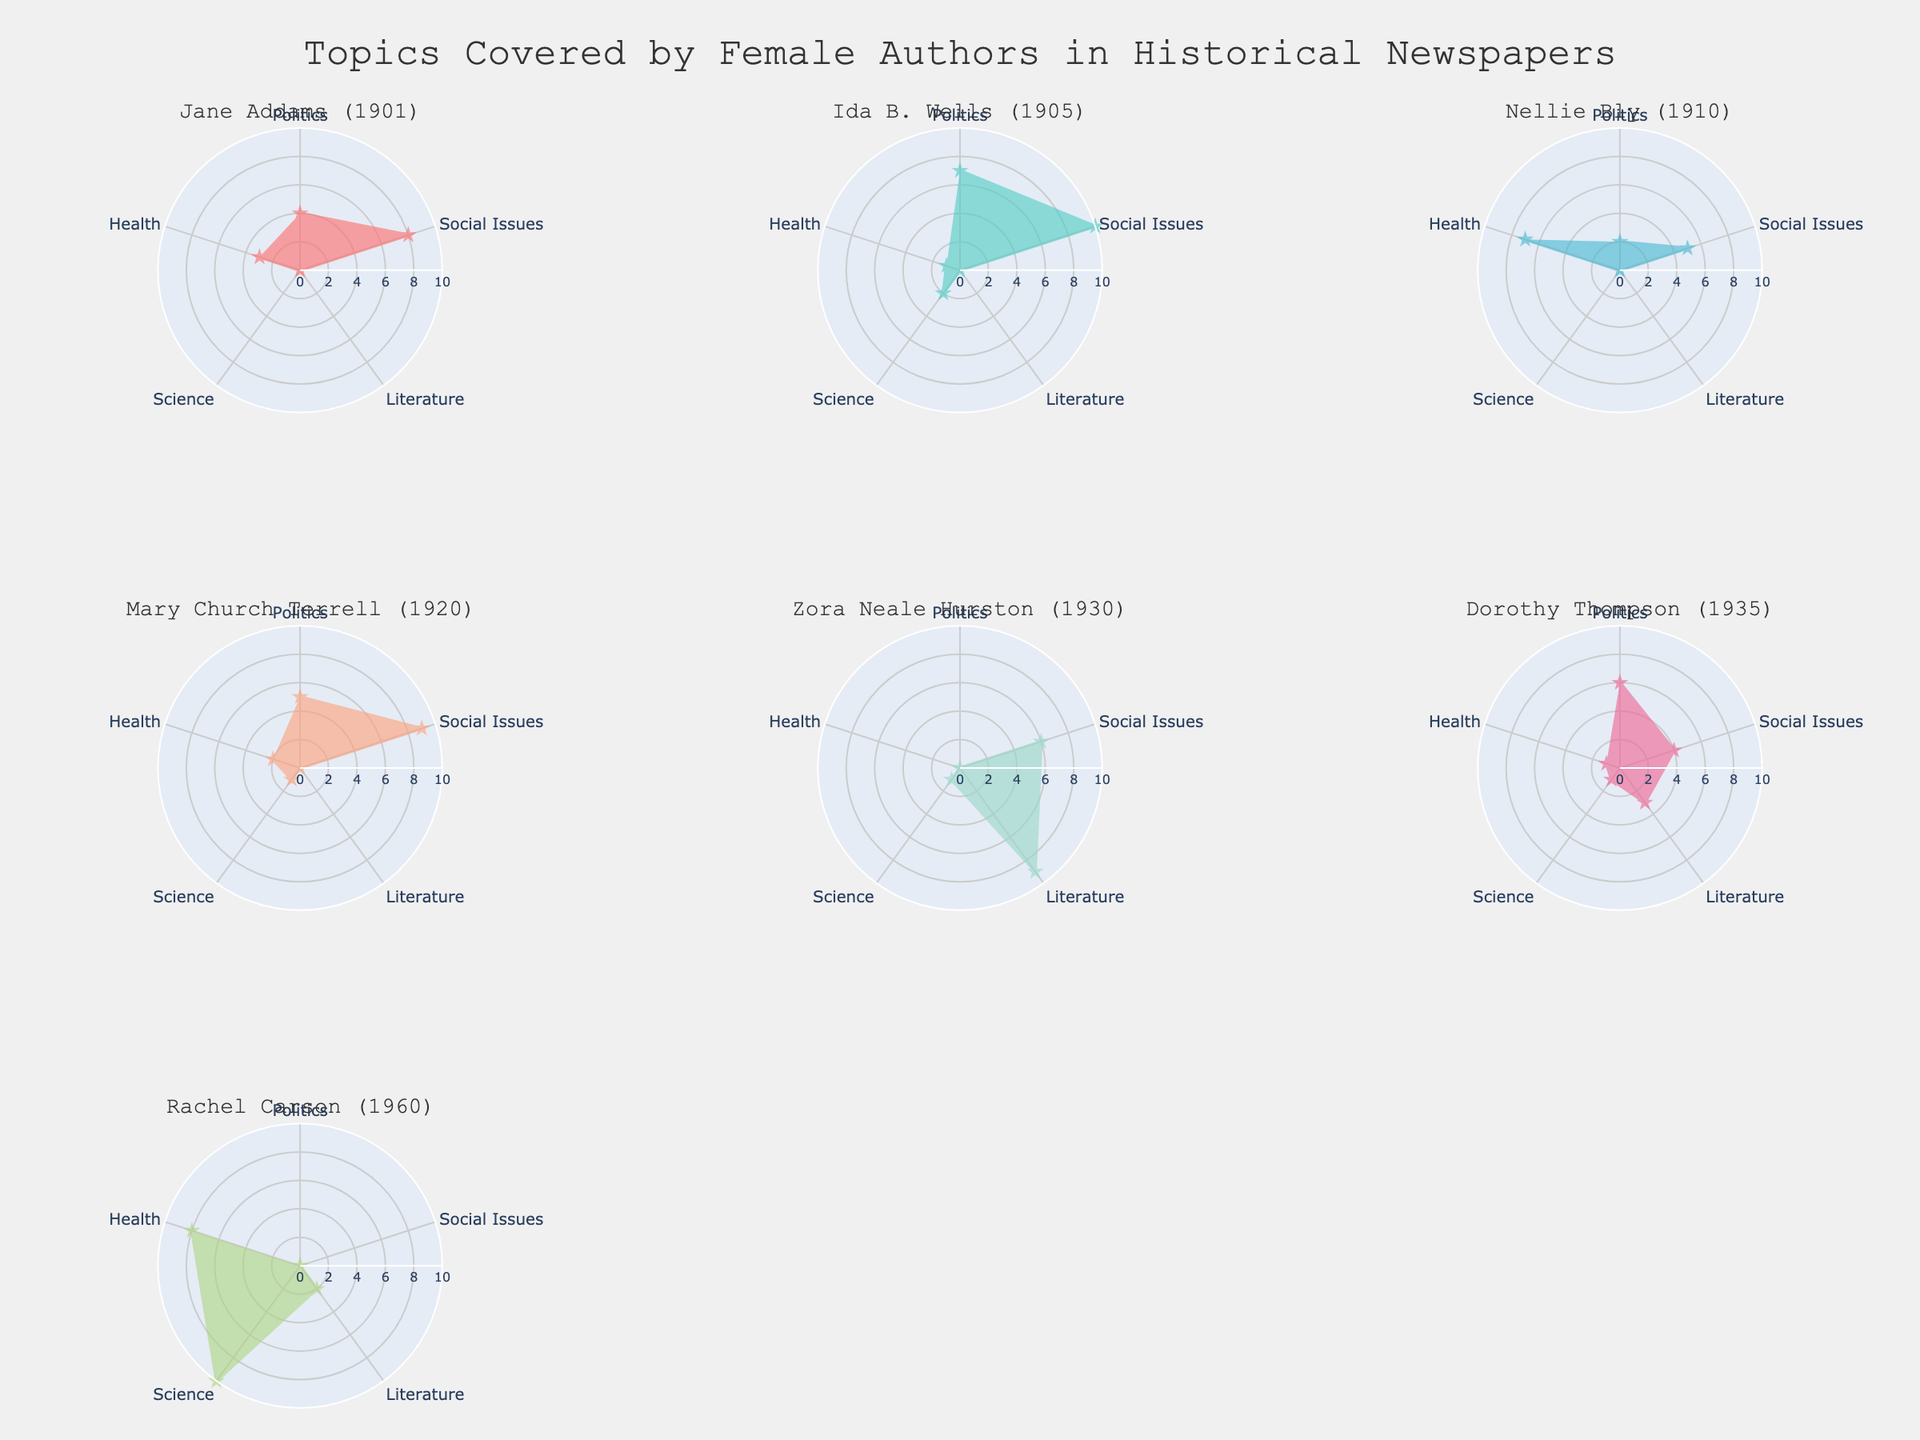What's the title of the figure? The title of the figure is usually placed prominently at the top center of the plot to provide an overview of what the chart represents. In this case, the title is centered and reads "Topics Covered by Female Authors in Historical Newspapers."
Answer: Topics Covered by Female Authors in Historical Newspapers What are the six categories represented on each radar chart? The categories can be seen around the perimeter of each radar subplot. They are: Politics, Social Issues, Literature, Science, Health.
Answer: Politics, Social Issues, Literature, Science, Health Which author has the most focus on Science? By examining each subplot, you can see that Rachel Carson has the highest value in the category Science with a score of 10.
Answer: Rachel Carson What is the sum of values for Jane Addams in all categories? By looking at Jane Addams' subplot and adding the values: Politics (4), Social Issues (8), Literature (0), Science (0), Health (3), we get: 4 + 8 + 0 + 0 + 3 = 15.
Answer: 15 Which authors contributed the most to Social Issues compared to Science? By comparing the values in the categories Social Issues and Science across all subplots, you can see that Ida B. Wells (10 vs 2), Mary Church Terrell (9 vs 1), and Zora Neale Hurston (6 vs 1) focused significantly more on Social Issues compared to Science.
Answer: Ida B. Wells, Mary Church Terrell, Zora Neale Hurston Who wrote the most on Health, and what is the value? By examining the Health category across all subplots, Nellie Bly has the highest value of 7, indicating she wrote the most on Health.
Answer: Nellie Bly Which author's contributions are the most balanced across different topics? By observing each subplot, Dorothy Thompson has relatively balanced contributions across the categories: Politics (6), Social Issues (4), Literature (3), Science (1), Health (1). These values are fairly even when compared to other authors.
Answer: Dorothy Thompson Between Jane Addams and Ida B. Wells, who wrote more on Politics and by how much? Comparing the Politics values: Jane Addams has a value of 4 and Ida B. Wells has a value of 7. Therefore, Ida B. Wells wrote 3 more on Politics than Jane Addams.
Answer: Ida B. Wells by 3 What is the average contribution to Literature across all authors? Summing the Literature values for all authors: Jane Addams (0), Ida B. Wells (0), Nellie Bly (0), Mary Church Terrell (0), Zora Neale Hurston (9), Dorothy Thompson (3), and Rachel Carson (2), we get 0 + 0 + 0 + 0 + 9 + 3 + 2 = 14. Dividing by the number of authors (7), the average is 14/7 = 2.
Answer: 2 